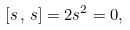<formula> <loc_0><loc_0><loc_500><loc_500>[ s \, , \, s ] = 2 s ^ { 2 } = 0 ,</formula> 